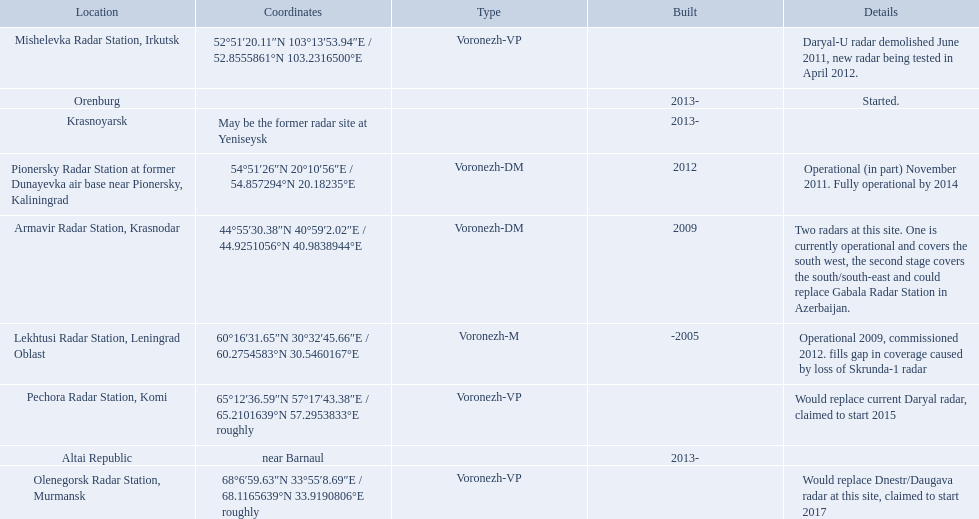Voronezh radar has locations where? Lekhtusi Radar Station, Leningrad Oblast, Armavir Radar Station, Krasnodar, Pionersky Radar Station at former Dunayevka air base near Pionersky, Kaliningrad, Mishelevka Radar Station, Irkutsk, Pechora Radar Station, Komi, Olenegorsk Radar Station, Murmansk, Krasnoyarsk, Altai Republic, Orenburg. Parse the full table in json format. {'header': ['Location', 'Coordinates', 'Type', 'Built', 'Details'], 'rows': [['Mishelevka Radar Station, Irkutsk', '52°51′20.11″N 103°13′53.94″E\ufeff / \ufeff52.8555861°N 103.2316500°E', 'Voronezh-VP', '', 'Daryal-U radar demolished June 2011, new radar being tested in April 2012.'], ['Orenburg', '', '', '2013-', 'Started.'], ['Krasnoyarsk', 'May be the former radar site at Yeniseysk', '', '2013-', ''], ['Pionersky Radar Station at former Dunayevka air base near Pionersky, Kaliningrad', '54°51′26″N 20°10′56″E\ufeff / \ufeff54.857294°N 20.18235°E', 'Voronezh-DM', '2012', 'Operational (in part) November 2011. Fully operational by 2014'], ['Armavir Radar Station, Krasnodar', '44°55′30.38″N 40°59′2.02″E\ufeff / \ufeff44.9251056°N 40.9838944°E', 'Voronezh-DM', '2009', 'Two radars at this site. One is currently operational and covers the south west, the second stage covers the south/south-east and could replace Gabala Radar Station in Azerbaijan.'], ['Lekhtusi Radar Station, Leningrad Oblast', '60°16′31.65″N 30°32′45.66″E\ufeff / \ufeff60.2754583°N 30.5460167°E', 'Voronezh-M', '-2005', 'Operational 2009, commissioned 2012. fills gap in coverage caused by loss of Skrunda-1 radar'], ['Pechora Radar Station, Komi', '65°12′36.59″N 57°17′43.38″E\ufeff / \ufeff65.2101639°N 57.2953833°E roughly', 'Voronezh-VP', '', 'Would replace current Daryal radar, claimed to start 2015'], ['Altai Republic', 'near Barnaul', '', '2013-', ''], ['Olenegorsk Radar Station, Murmansk', '68°6′59.63″N 33°55′8.69″E\ufeff / \ufeff68.1165639°N 33.9190806°E roughly', 'Voronezh-VP', '', 'Would replace Dnestr/Daugava radar at this site, claimed to start 2017']]} Which of these locations have know coordinates? Lekhtusi Radar Station, Leningrad Oblast, Armavir Radar Station, Krasnodar, Pionersky Radar Station at former Dunayevka air base near Pionersky, Kaliningrad, Mishelevka Radar Station, Irkutsk, Pechora Radar Station, Komi, Olenegorsk Radar Station, Murmansk. Which of these locations has coordinates of 60deg16'31.65''n 30deg32'45.66''e / 60.2754583degn 30.5460167dege? Lekhtusi Radar Station, Leningrad Oblast. 